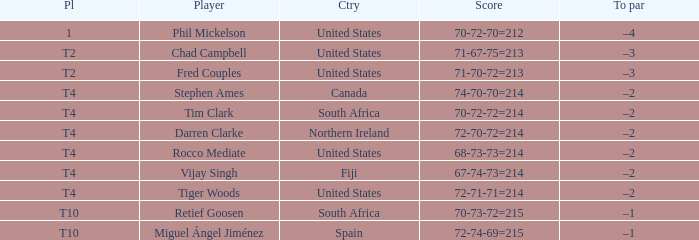What was the score for Spain? 72-74-69=215. 